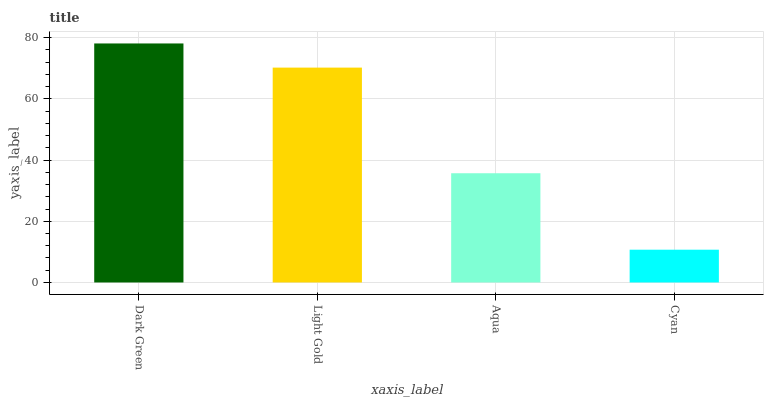Is Cyan the minimum?
Answer yes or no. Yes. Is Dark Green the maximum?
Answer yes or no. Yes. Is Light Gold the minimum?
Answer yes or no. No. Is Light Gold the maximum?
Answer yes or no. No. Is Dark Green greater than Light Gold?
Answer yes or no. Yes. Is Light Gold less than Dark Green?
Answer yes or no. Yes. Is Light Gold greater than Dark Green?
Answer yes or no. No. Is Dark Green less than Light Gold?
Answer yes or no. No. Is Light Gold the high median?
Answer yes or no. Yes. Is Aqua the low median?
Answer yes or no. Yes. Is Dark Green the high median?
Answer yes or no. No. Is Dark Green the low median?
Answer yes or no. No. 